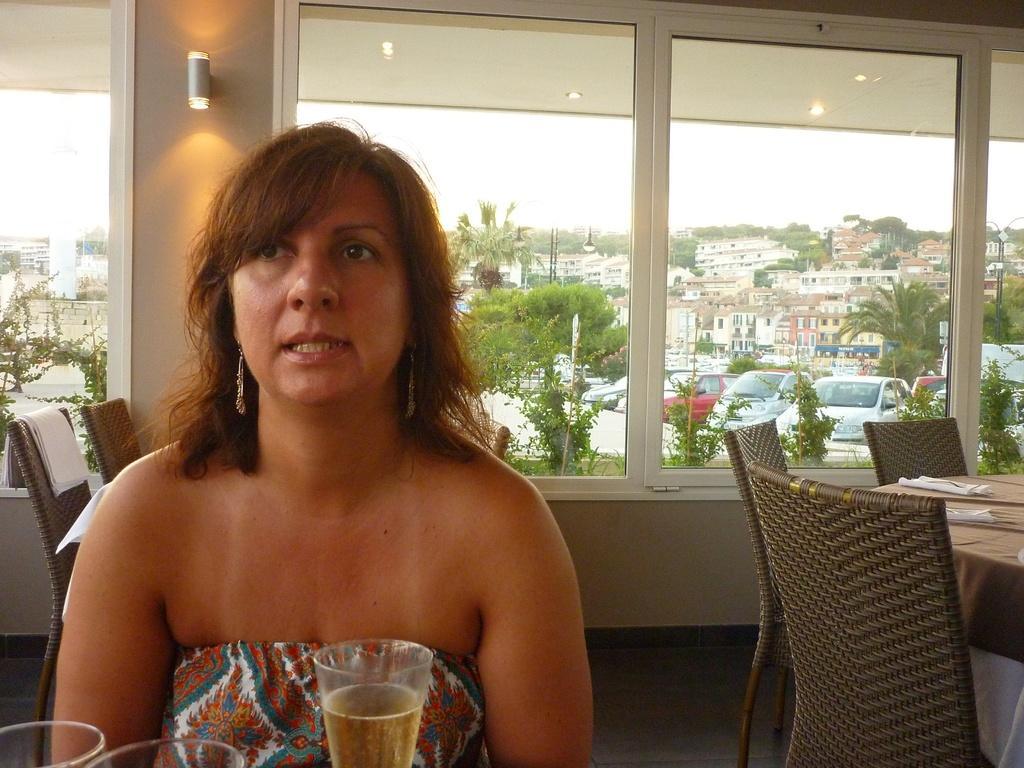How would you summarize this image in a sentence or two? This woman is sitting in the chair is having a glass in front of her. In the background there are glass windows through which new cars are appearing and there are also buildings which we can see. These are the trees and this is the sky. 